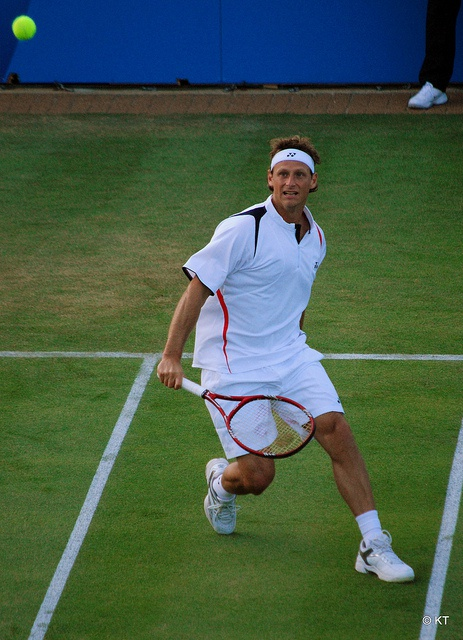Describe the objects in this image and their specific colors. I can see people in navy, darkgray, olive, maroon, and lavender tones, tennis racket in navy, darkgray, gray, and black tones, people in navy, black, darkgray, gray, and blue tones, and sports ball in navy, lime, green, and lightgreen tones in this image. 